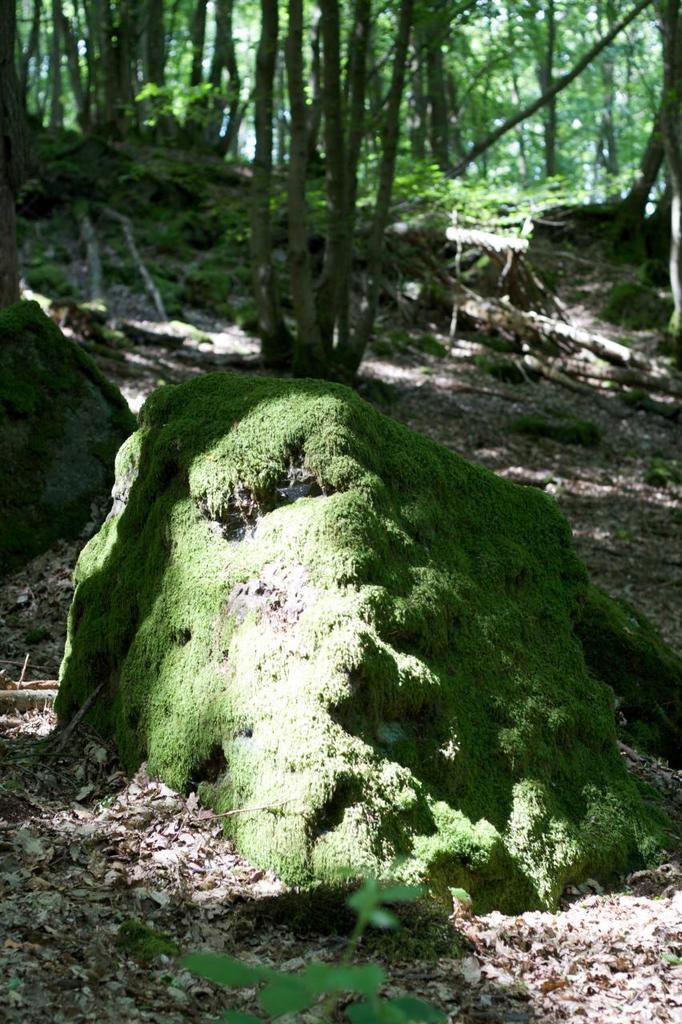Please provide a concise description of this image. In this image, we can see the ground with some dried leaves. We can also see some plants, trees, stones. 